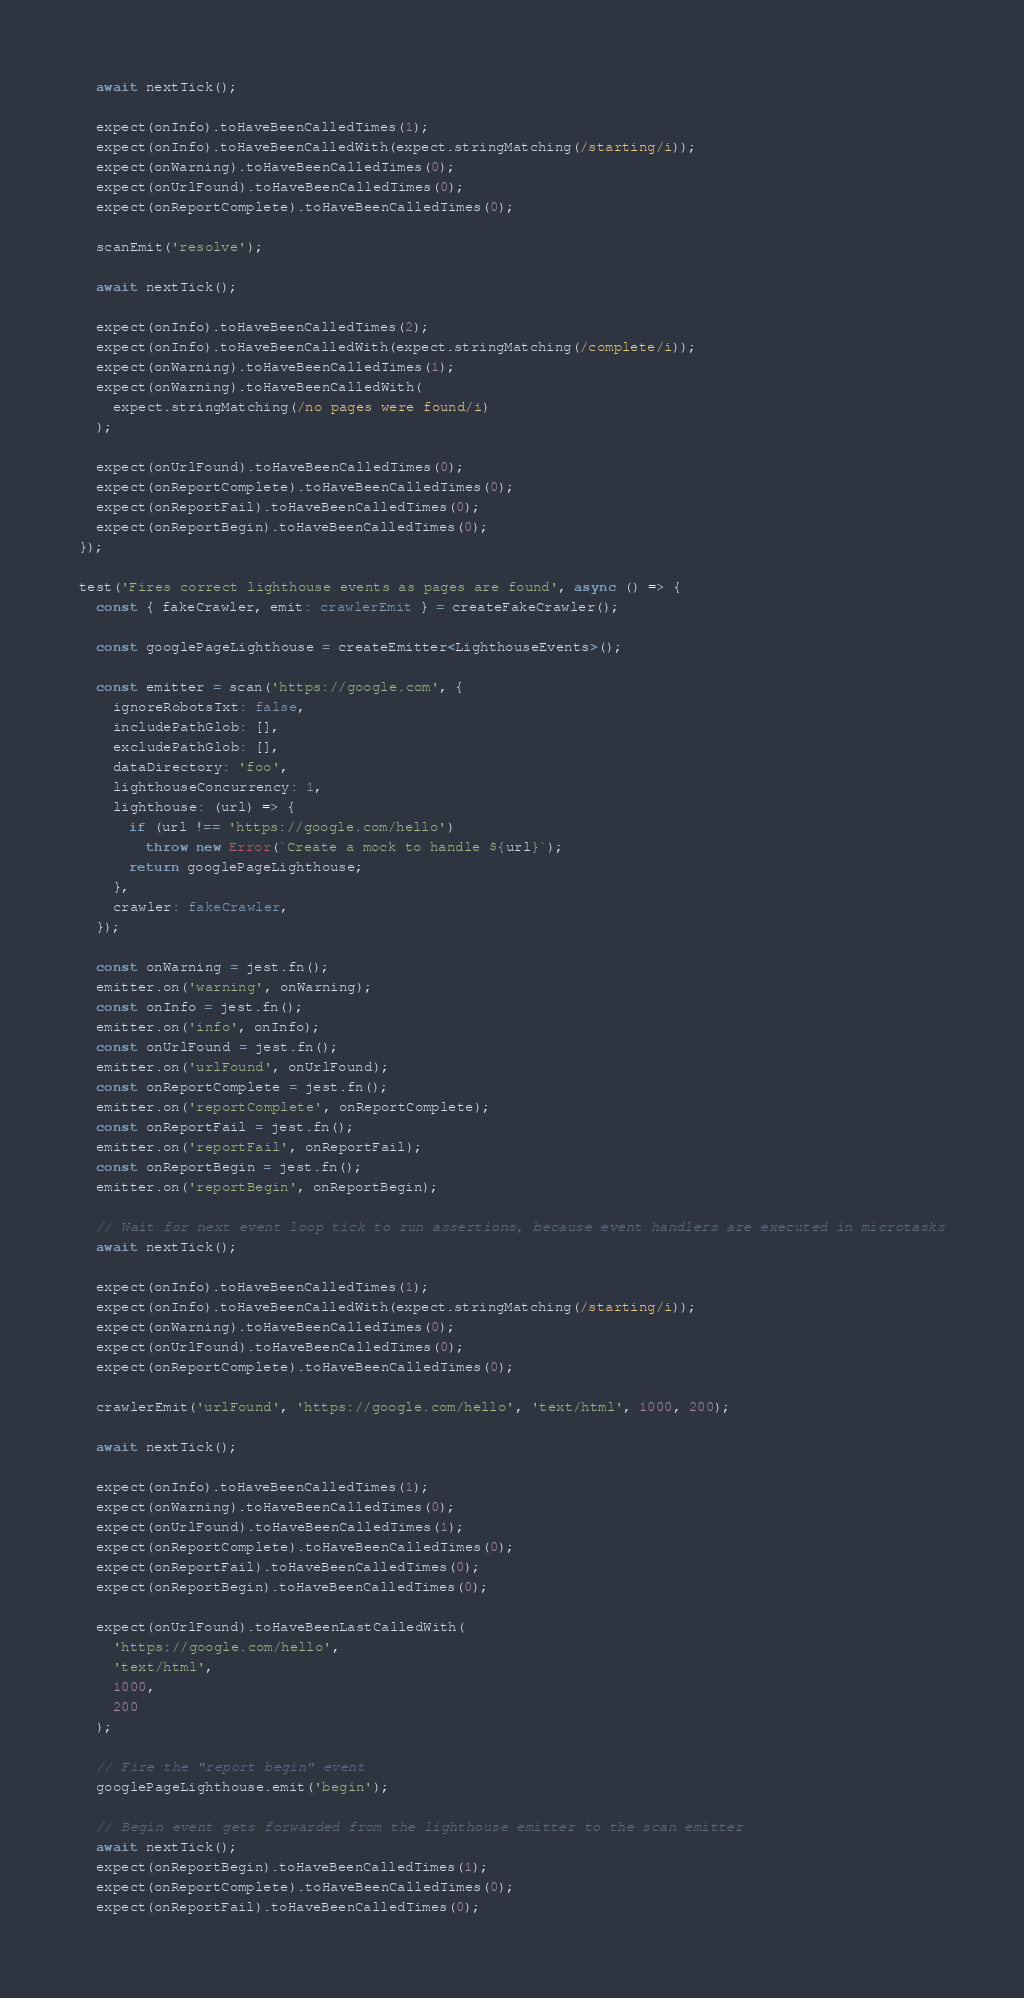<code> <loc_0><loc_0><loc_500><loc_500><_TypeScript_>  await nextTick();

  expect(onInfo).toHaveBeenCalledTimes(1);
  expect(onInfo).toHaveBeenCalledWith(expect.stringMatching(/starting/i));
  expect(onWarning).toHaveBeenCalledTimes(0);
  expect(onUrlFound).toHaveBeenCalledTimes(0);
  expect(onReportComplete).toHaveBeenCalledTimes(0);

  scanEmit('resolve');

  await nextTick();

  expect(onInfo).toHaveBeenCalledTimes(2);
  expect(onInfo).toHaveBeenCalledWith(expect.stringMatching(/complete/i));
  expect(onWarning).toHaveBeenCalledTimes(1);
  expect(onWarning).toHaveBeenCalledWith(
    expect.stringMatching(/no pages were found/i)
  );

  expect(onUrlFound).toHaveBeenCalledTimes(0);
  expect(onReportComplete).toHaveBeenCalledTimes(0);
  expect(onReportFail).toHaveBeenCalledTimes(0);
  expect(onReportBegin).toHaveBeenCalledTimes(0);
});

test('Fires correct lighthouse events as pages are found', async () => {
  const { fakeCrawler, emit: crawlerEmit } = createFakeCrawler();

  const googlePageLighthouse = createEmitter<LighthouseEvents>();

  const emitter = scan('https://google.com', {
    ignoreRobotsTxt: false,
    includePathGlob: [],
    excludePathGlob: [],
    dataDirectory: 'foo',
    lighthouseConcurrency: 1,
    lighthouse: (url) => {
      if (url !== 'https://google.com/hello')
        throw new Error(`Create a mock to handle ${url}`);
      return googlePageLighthouse;
    },
    crawler: fakeCrawler,
  });

  const onWarning = jest.fn();
  emitter.on('warning', onWarning);
  const onInfo = jest.fn();
  emitter.on('info', onInfo);
  const onUrlFound = jest.fn();
  emitter.on('urlFound', onUrlFound);
  const onReportComplete = jest.fn();
  emitter.on('reportComplete', onReportComplete);
  const onReportFail = jest.fn();
  emitter.on('reportFail', onReportFail);
  const onReportBegin = jest.fn();
  emitter.on('reportBegin', onReportBegin);

  // Wait for next event loop tick to run assertions, because event handlers are executed in microtasks
  await nextTick();

  expect(onInfo).toHaveBeenCalledTimes(1);
  expect(onInfo).toHaveBeenCalledWith(expect.stringMatching(/starting/i));
  expect(onWarning).toHaveBeenCalledTimes(0);
  expect(onUrlFound).toHaveBeenCalledTimes(0);
  expect(onReportComplete).toHaveBeenCalledTimes(0);

  crawlerEmit('urlFound', 'https://google.com/hello', 'text/html', 1000, 200);

  await nextTick();

  expect(onInfo).toHaveBeenCalledTimes(1);
  expect(onWarning).toHaveBeenCalledTimes(0);
  expect(onUrlFound).toHaveBeenCalledTimes(1);
  expect(onReportComplete).toHaveBeenCalledTimes(0);
  expect(onReportFail).toHaveBeenCalledTimes(0);
  expect(onReportBegin).toHaveBeenCalledTimes(0);

  expect(onUrlFound).toHaveBeenLastCalledWith(
    'https://google.com/hello',
    'text/html',
    1000,
    200
  );

  // Fire the "report begin" event
  googlePageLighthouse.emit('begin');

  // Begin event gets forwarded from the lighthouse emitter to the scan emitter
  await nextTick();
  expect(onReportBegin).toHaveBeenCalledTimes(1);
  expect(onReportComplete).toHaveBeenCalledTimes(0);
  expect(onReportFail).toHaveBeenCalledTimes(0);
</code> 